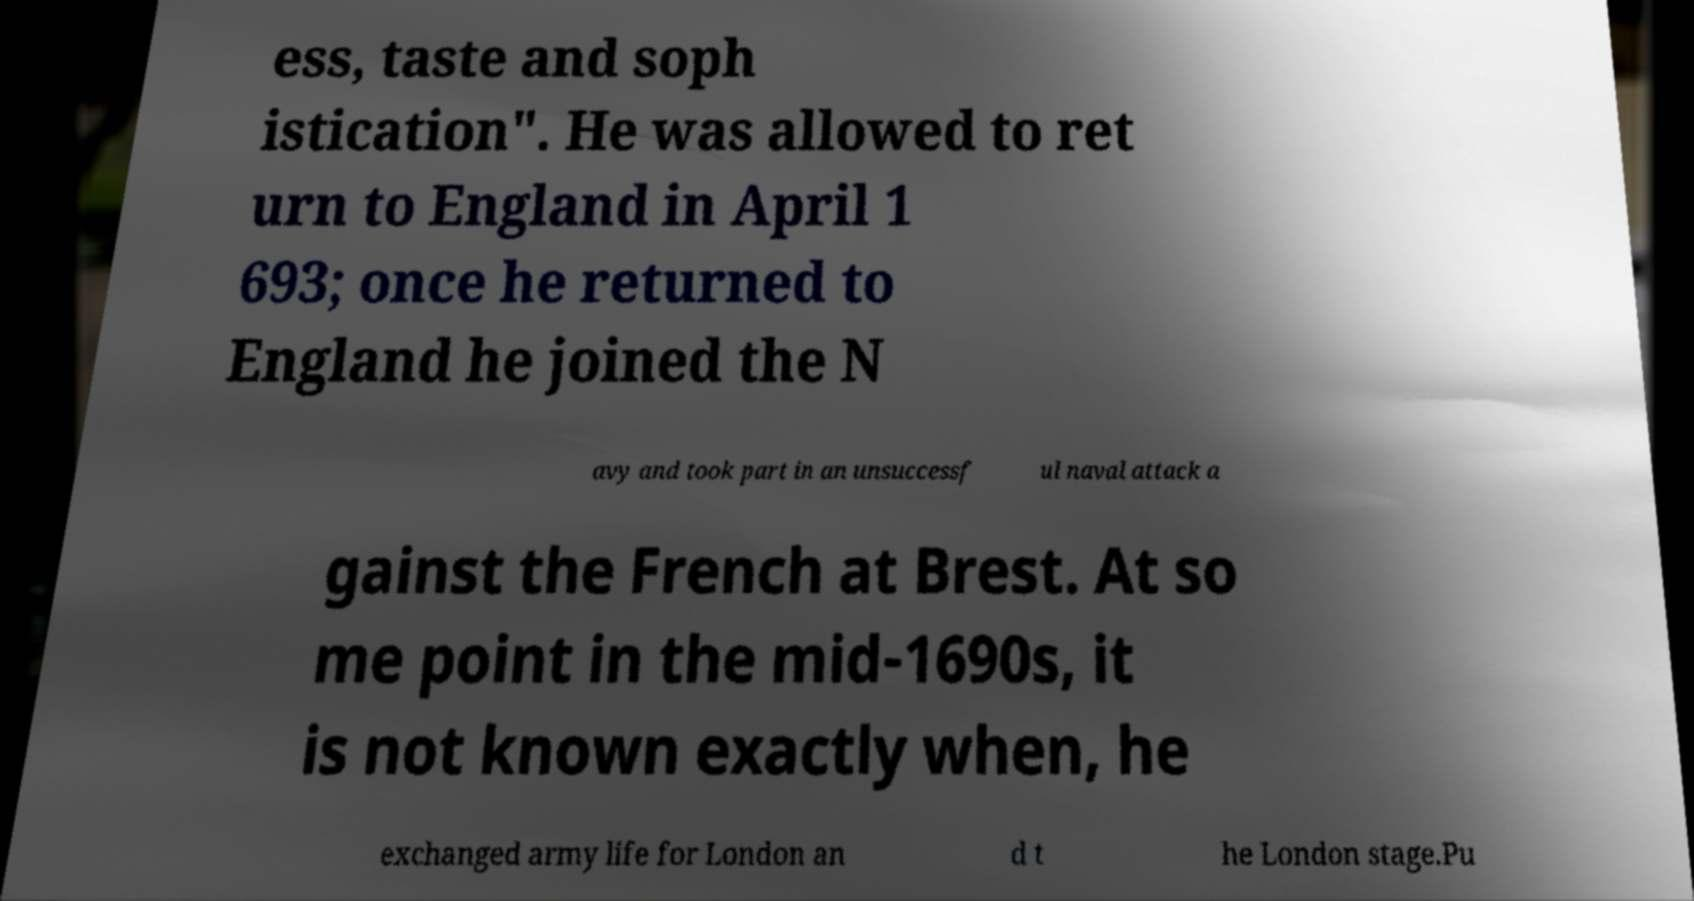Could you extract and type out the text from this image? ess, taste and soph istication". He was allowed to ret urn to England in April 1 693; once he returned to England he joined the N avy and took part in an unsuccessf ul naval attack a gainst the French at Brest. At so me point in the mid-1690s, it is not known exactly when, he exchanged army life for London an d t he London stage.Pu 